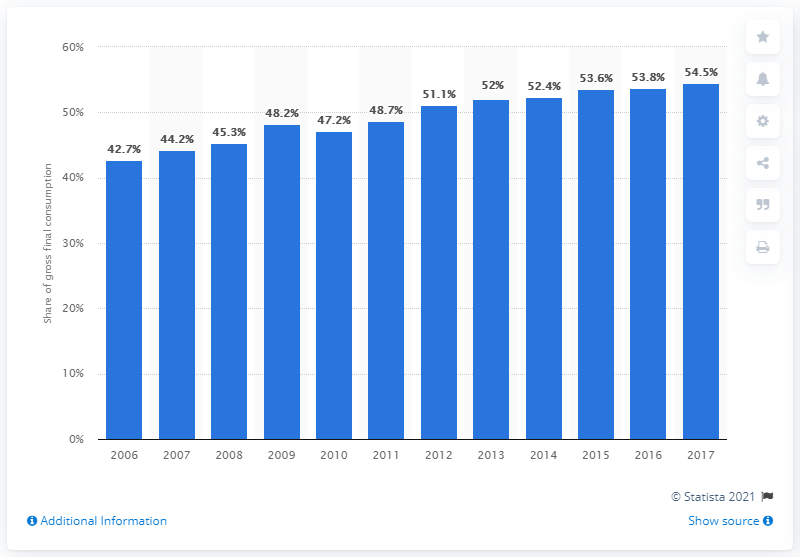Outline some significant characteristics in this image. In Sweden, the share of energy from renewable sources increased from 54.5% in 2006 to 64.2% in 2017. In Sweden, the percentage of energy from renewable sources increased from 2006 to 2017, reaching a total of 42.7% during this period. 